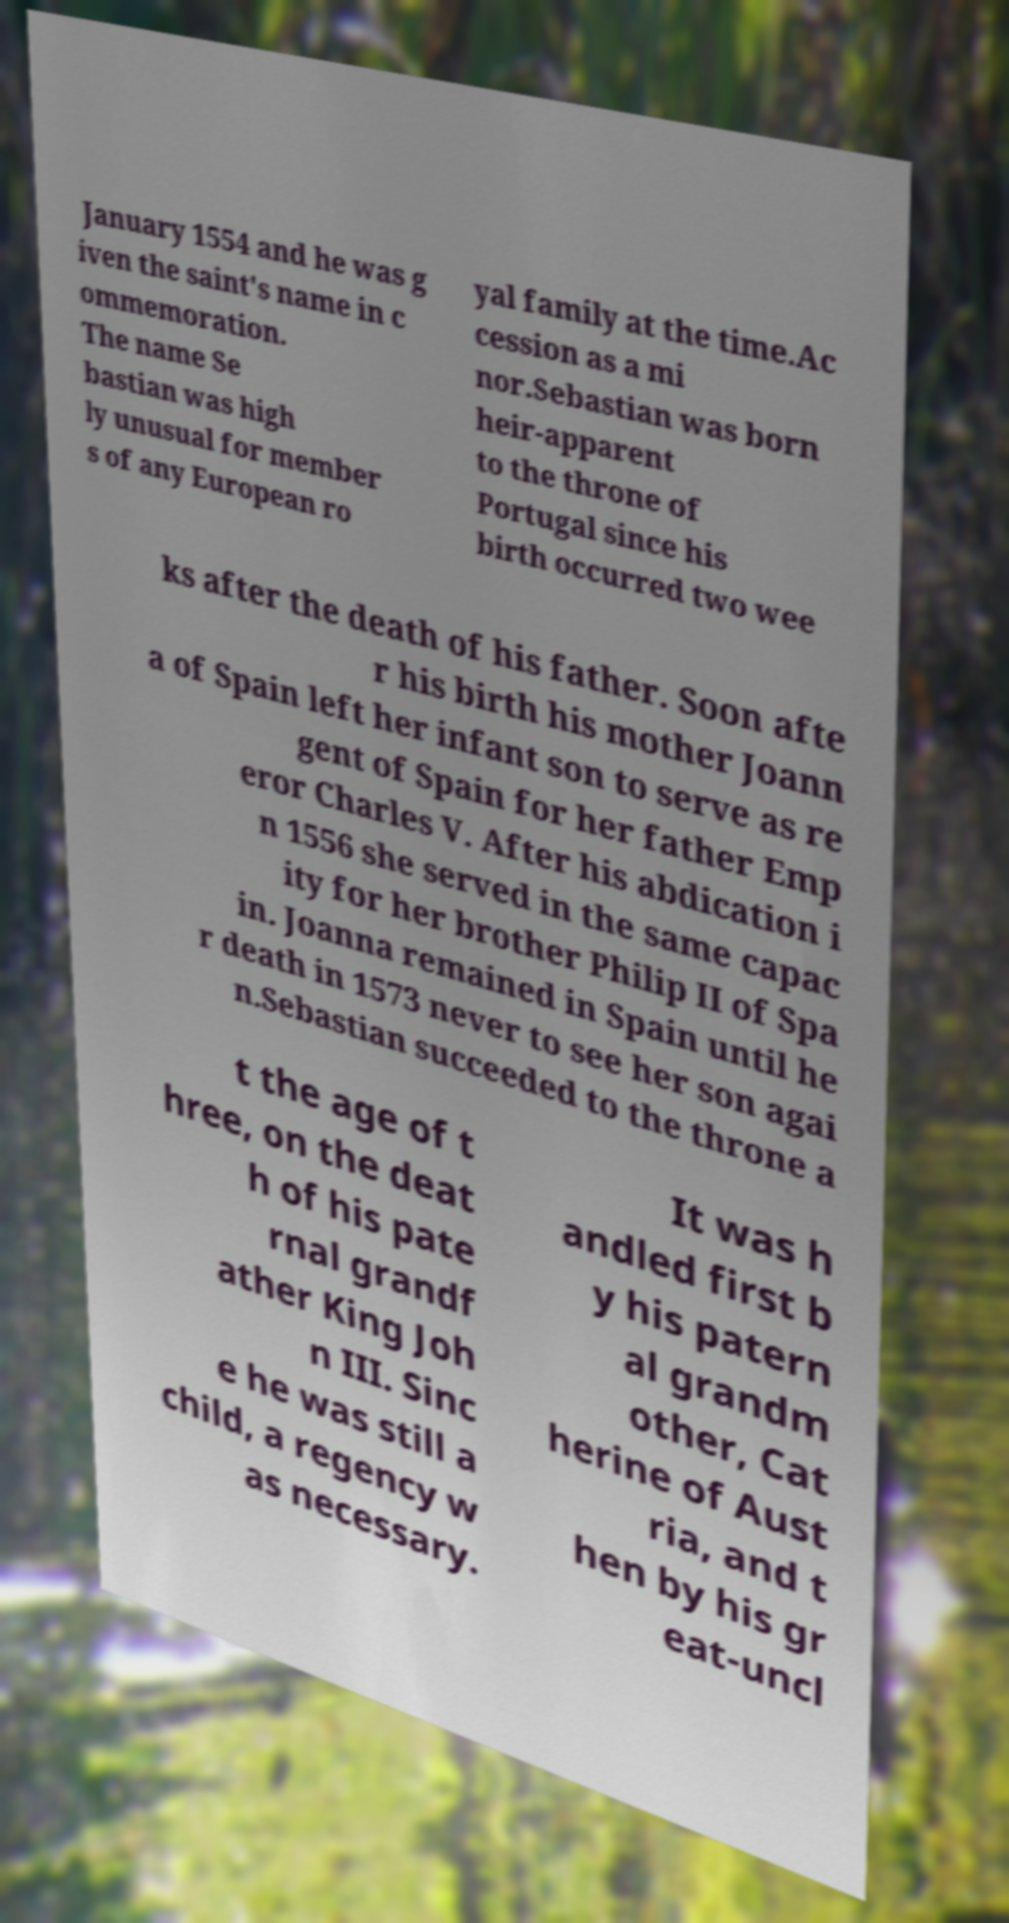Please identify and transcribe the text found in this image. January 1554 and he was g iven the saint's name in c ommemoration. The name Se bastian was high ly unusual for member s of any European ro yal family at the time.Ac cession as a mi nor.Sebastian was born heir-apparent to the throne of Portugal since his birth occurred two wee ks after the death of his father. Soon afte r his birth his mother Joann a of Spain left her infant son to serve as re gent of Spain for her father Emp eror Charles V. After his abdication i n 1556 she served in the same capac ity for her brother Philip II of Spa in. Joanna remained in Spain until he r death in 1573 never to see her son agai n.Sebastian succeeded to the throne a t the age of t hree, on the deat h of his pate rnal grandf ather King Joh n III. Sinc e he was still a child, a regency w as necessary. It was h andled first b y his patern al grandm other, Cat herine of Aust ria, and t hen by his gr eat-uncl 